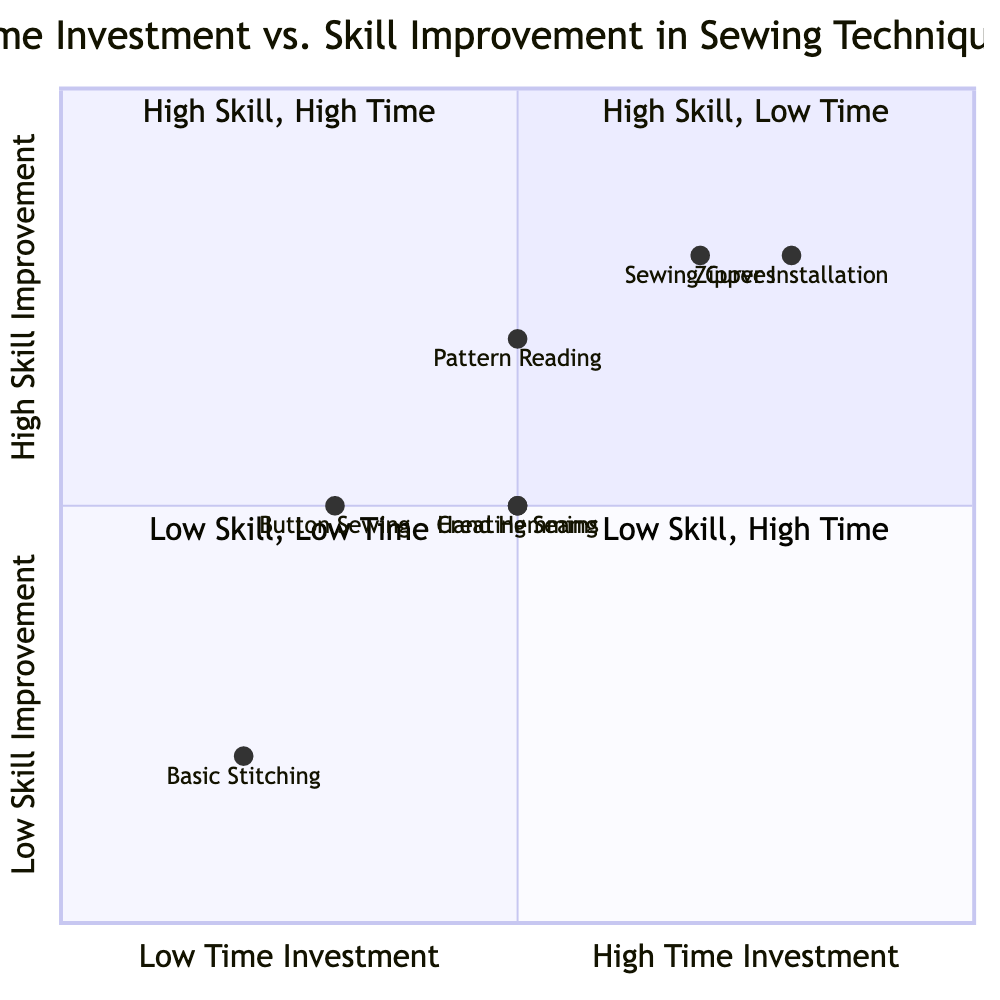What is the skill improvement rating for Basic Stitching? Basic Stitching is positioned in the quadrant that signifies low skill improvement, indicated by its y-coordinate value, which correlates to the "Low" skill improvement category on the y-axis of the chart.
Answer: Low How many sewing techniques are in the High Skill, Low Time quadrant? The diagram shows only one technique, which is Basic Stitching, categorized under the High Skill, Low Time quadrant based on its coordinates.
Answer: 1 What sewing technique has the highest time investment? Zipper Installation is located at the far right of the x-axis, indicating it has the highest time investment among the techniques represented in the chart.
Answer: Zipper Installation Which sewing technique combines both high skill and high time investment? Zipper Installation and Sewing Curves are both located in the High Skill, High Time quadrant, indicated by their positioning being in the upper-right section of the quadrants.
Answer: Zipper Installation, Sewing Curves What is the average skill improvement for techniques with low time investment? Techniques with low time investment include Basic Stitching and Button Sewing, which have skill improvements of low and medium respectively, leading to an average skill improvement of 0.5 in the y-coordinate scale.
Answer: Medium Which two techniques have the same skill improvement but different time investments? Hand Hemming and Creating Seams both display medium skill improvement, though their time investments differ, with Hand Hemming at medium and Creating Seams also at medium, but their coordinates give them a separate identification.
Answer: Hand Hemming, Creating Seams What coordinates represent the Button Sewing technique? Button Sewing is represented by the coordinates [0.3, 0.5], meaning its time investment is low, and skill improvement is medium, confirmed by its specific position in the diagram.
Answer: 0.3, 0.5 Which technique has both medium time investment and high skill improvement? Pattern Reading is the only technique that has a medium time investment while achieving a high level of skill improvement, identified by its unique positioning in the quadrant.
Answer: Pattern Reading 